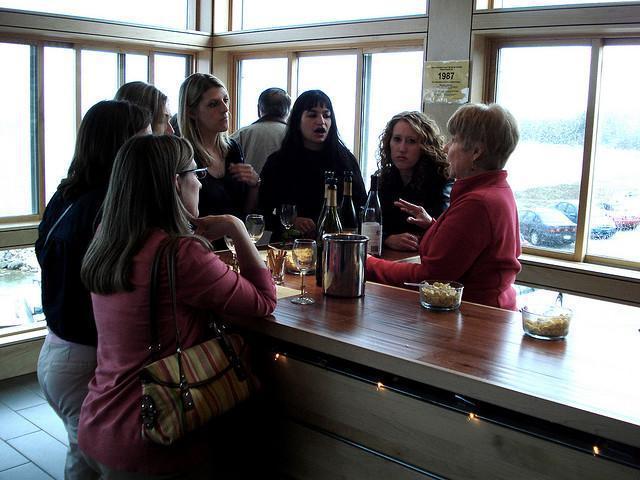How many people are in the image?
Give a very brief answer. 8. How many people are there?
Give a very brief answer. 7. 